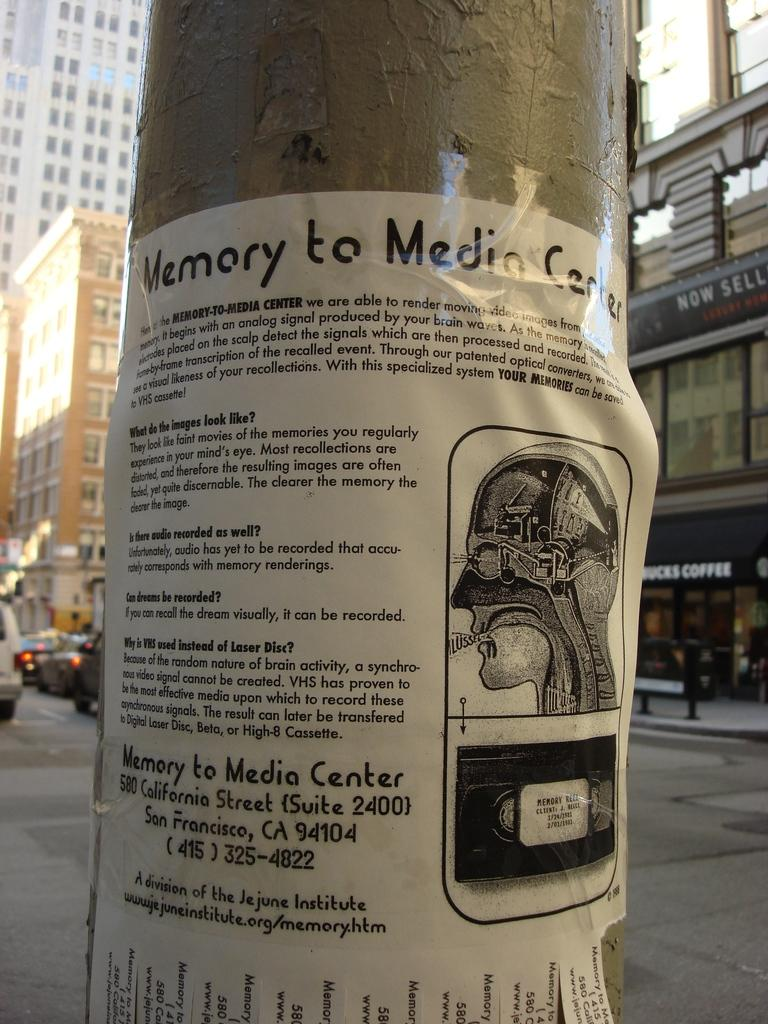What is located at the front of the image? There is a poster in the front of the image. What can be seen in the background of the image? There are buildings and a bench in the background of the image. Are there any vehicles visible in the image? Yes, vehicles are present in the background of the image. How many apples can be seen on the poster in the image? There is no apple present on the poster in the image. What type of metal is the bench made of in the image? The type of metal the bench is made of cannot be determined from the image. 